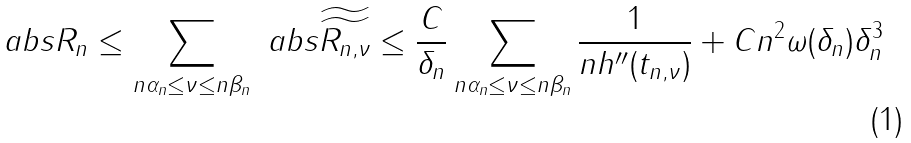<formula> <loc_0><loc_0><loc_500><loc_500>\ a b s { R _ { n } } \leq \sum _ { n \alpha _ { n } \leq \nu \leq n \beta _ { n } } \ a b s { \widetilde { \widetilde { R _ { n , \nu } } } } \leq \frac { C } { \delta _ { n } } \sum _ { n \alpha _ { n } \leq \nu \leq n \beta _ { n } } \frac { 1 } { n h ^ { \prime \prime } ( t _ { n , \nu } ) } + C n ^ { 2 } \omega ( \delta _ { n } ) \delta _ { n } ^ { 3 }</formula> 